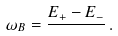Convert formula to latex. <formula><loc_0><loc_0><loc_500><loc_500>\omega _ { B } = \frac { E _ { + } - E _ { - } } { } \, .</formula> 